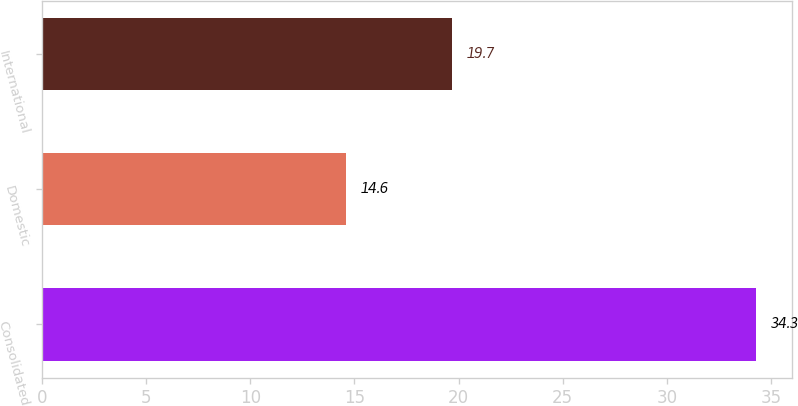<chart> <loc_0><loc_0><loc_500><loc_500><bar_chart><fcel>Consolidated<fcel>Domestic<fcel>International<nl><fcel>34.3<fcel>14.6<fcel>19.7<nl></chart> 